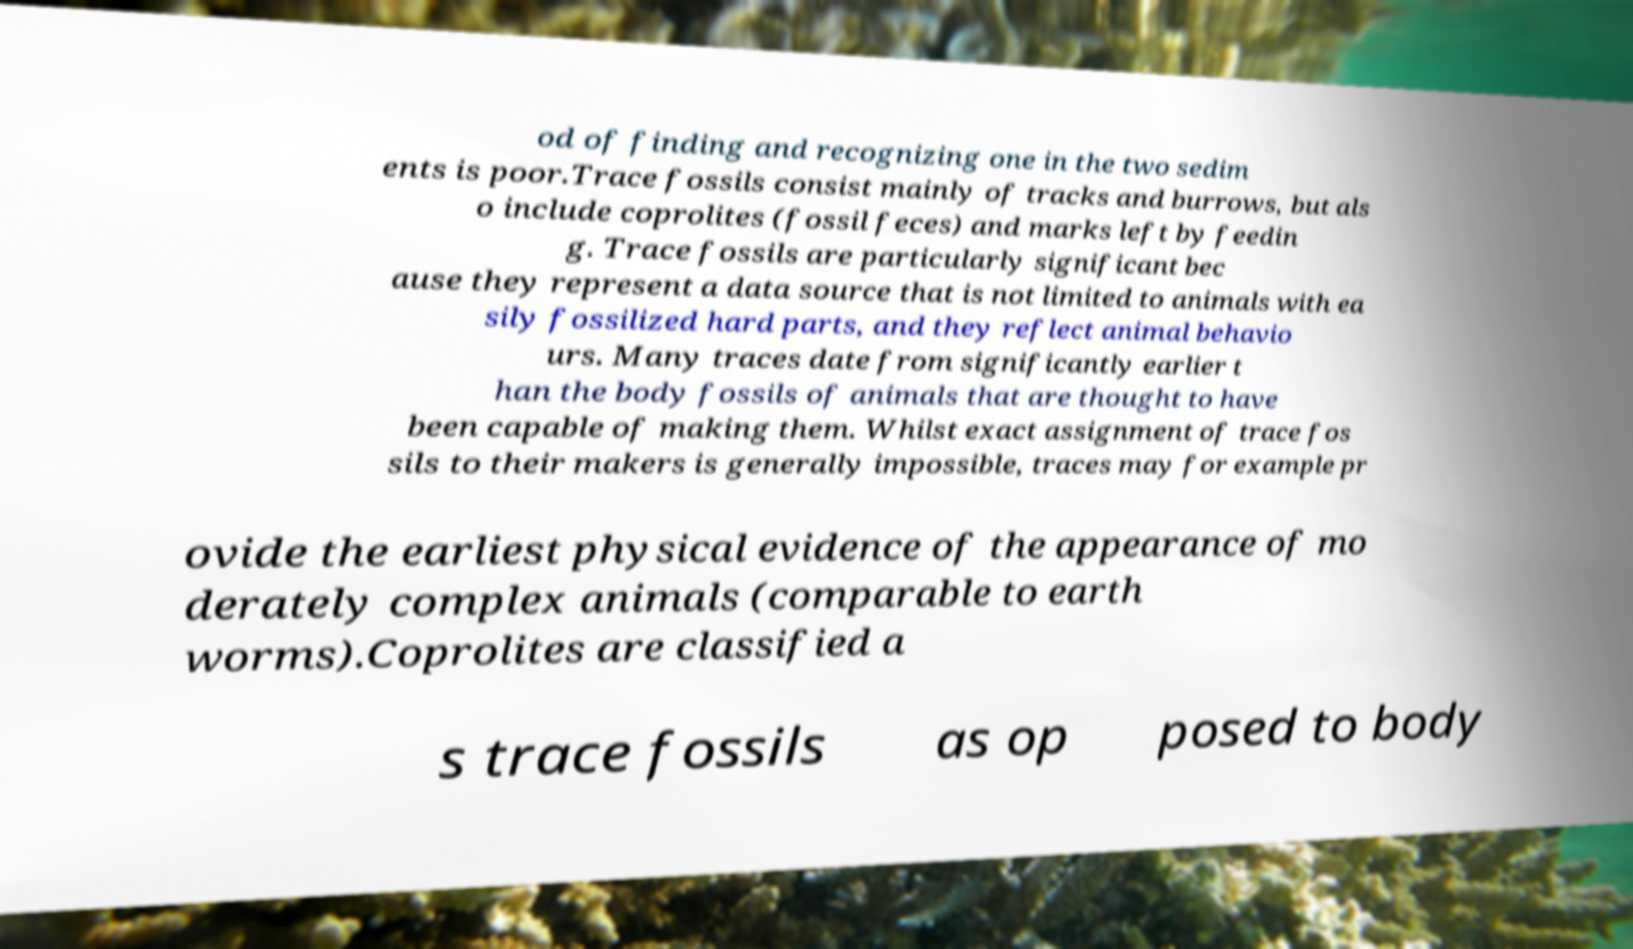For documentation purposes, I need the text within this image transcribed. Could you provide that? od of finding and recognizing one in the two sedim ents is poor.Trace fossils consist mainly of tracks and burrows, but als o include coprolites (fossil feces) and marks left by feedin g. Trace fossils are particularly significant bec ause they represent a data source that is not limited to animals with ea sily fossilized hard parts, and they reflect animal behavio urs. Many traces date from significantly earlier t han the body fossils of animals that are thought to have been capable of making them. Whilst exact assignment of trace fos sils to their makers is generally impossible, traces may for example pr ovide the earliest physical evidence of the appearance of mo derately complex animals (comparable to earth worms).Coprolites are classified a s trace fossils as op posed to body 